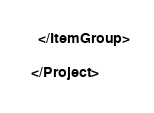Convert code to text. <code><loc_0><loc_0><loc_500><loc_500><_XML_>  </ItemGroup>

</Project>
</code> 